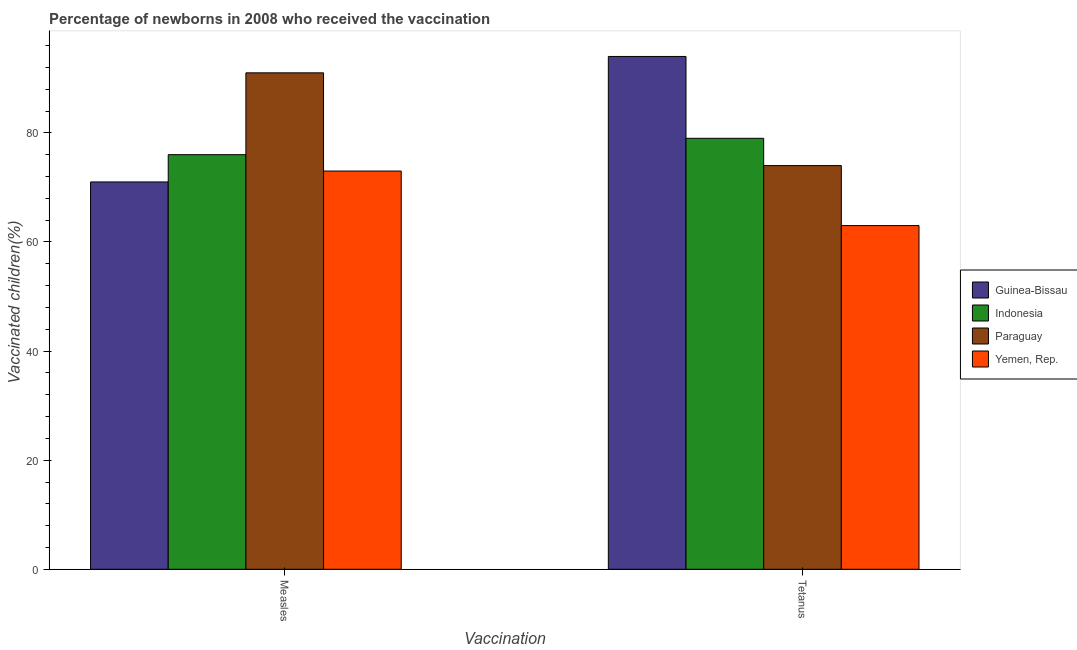Are the number of bars per tick equal to the number of legend labels?
Your answer should be very brief. Yes. Are the number of bars on each tick of the X-axis equal?
Your response must be concise. Yes. How many bars are there on the 1st tick from the left?
Ensure brevity in your answer.  4. How many bars are there on the 2nd tick from the right?
Provide a short and direct response. 4. What is the label of the 2nd group of bars from the left?
Give a very brief answer. Tetanus. What is the percentage of newborns who received vaccination for measles in Guinea-Bissau?
Ensure brevity in your answer.  71. Across all countries, what is the maximum percentage of newborns who received vaccination for measles?
Your response must be concise. 91. Across all countries, what is the minimum percentage of newborns who received vaccination for measles?
Your response must be concise. 71. In which country was the percentage of newborns who received vaccination for measles maximum?
Provide a succinct answer. Paraguay. In which country was the percentage of newborns who received vaccination for tetanus minimum?
Ensure brevity in your answer.  Yemen, Rep. What is the total percentage of newborns who received vaccination for tetanus in the graph?
Your answer should be very brief. 310. What is the difference between the percentage of newborns who received vaccination for tetanus in Guinea-Bissau and that in Paraguay?
Keep it short and to the point. 20. What is the difference between the percentage of newborns who received vaccination for measles in Indonesia and the percentage of newborns who received vaccination for tetanus in Paraguay?
Your response must be concise. 2. What is the average percentage of newborns who received vaccination for tetanus per country?
Your answer should be very brief. 77.5. What is the difference between the percentage of newborns who received vaccination for tetanus and percentage of newborns who received vaccination for measles in Yemen, Rep.?
Offer a very short reply. -10. What is the ratio of the percentage of newborns who received vaccination for measles in Yemen, Rep. to that in Paraguay?
Ensure brevity in your answer.  0.8. Is the percentage of newborns who received vaccination for measles in Paraguay less than that in Indonesia?
Keep it short and to the point. No. In how many countries, is the percentage of newborns who received vaccination for measles greater than the average percentage of newborns who received vaccination for measles taken over all countries?
Provide a succinct answer. 1. What does the 1st bar from the left in Tetanus represents?
Offer a terse response. Guinea-Bissau. What does the 1st bar from the right in Measles represents?
Give a very brief answer. Yemen, Rep. How many bars are there?
Make the answer very short. 8. Are all the bars in the graph horizontal?
Offer a very short reply. No. How many countries are there in the graph?
Keep it short and to the point. 4. Are the values on the major ticks of Y-axis written in scientific E-notation?
Provide a short and direct response. No. Does the graph contain grids?
Ensure brevity in your answer.  No. Where does the legend appear in the graph?
Your answer should be very brief. Center right. How many legend labels are there?
Provide a succinct answer. 4. How are the legend labels stacked?
Provide a short and direct response. Vertical. What is the title of the graph?
Your answer should be compact. Percentage of newborns in 2008 who received the vaccination. Does "French Polynesia" appear as one of the legend labels in the graph?
Make the answer very short. No. What is the label or title of the X-axis?
Give a very brief answer. Vaccination. What is the label or title of the Y-axis?
Your response must be concise. Vaccinated children(%)
. What is the Vaccinated children(%)
 of Guinea-Bissau in Measles?
Provide a short and direct response. 71. What is the Vaccinated children(%)
 of Paraguay in Measles?
Your response must be concise. 91. What is the Vaccinated children(%)
 of Guinea-Bissau in Tetanus?
Your response must be concise. 94. What is the Vaccinated children(%)
 in Indonesia in Tetanus?
Your response must be concise. 79. Across all Vaccination, what is the maximum Vaccinated children(%)
 of Guinea-Bissau?
Your answer should be compact. 94. Across all Vaccination, what is the maximum Vaccinated children(%)
 of Indonesia?
Your answer should be very brief. 79. Across all Vaccination, what is the maximum Vaccinated children(%)
 in Paraguay?
Give a very brief answer. 91. Across all Vaccination, what is the minimum Vaccinated children(%)
 in Indonesia?
Offer a terse response. 76. What is the total Vaccinated children(%)
 in Guinea-Bissau in the graph?
Give a very brief answer. 165. What is the total Vaccinated children(%)
 of Indonesia in the graph?
Your answer should be very brief. 155. What is the total Vaccinated children(%)
 in Paraguay in the graph?
Ensure brevity in your answer.  165. What is the total Vaccinated children(%)
 in Yemen, Rep. in the graph?
Provide a short and direct response. 136. What is the difference between the Vaccinated children(%)
 of Guinea-Bissau in Measles and that in Tetanus?
Give a very brief answer. -23. What is the difference between the Vaccinated children(%)
 in Guinea-Bissau in Measles and the Vaccinated children(%)
 in Paraguay in Tetanus?
Give a very brief answer. -3. What is the difference between the Vaccinated children(%)
 in Guinea-Bissau in Measles and the Vaccinated children(%)
 in Yemen, Rep. in Tetanus?
Provide a short and direct response. 8. What is the difference between the Vaccinated children(%)
 of Indonesia in Measles and the Vaccinated children(%)
 of Paraguay in Tetanus?
Make the answer very short. 2. What is the difference between the Vaccinated children(%)
 in Paraguay in Measles and the Vaccinated children(%)
 in Yemen, Rep. in Tetanus?
Provide a succinct answer. 28. What is the average Vaccinated children(%)
 in Guinea-Bissau per Vaccination?
Offer a very short reply. 82.5. What is the average Vaccinated children(%)
 of Indonesia per Vaccination?
Ensure brevity in your answer.  77.5. What is the average Vaccinated children(%)
 in Paraguay per Vaccination?
Ensure brevity in your answer.  82.5. What is the average Vaccinated children(%)
 of Yemen, Rep. per Vaccination?
Provide a succinct answer. 68. What is the difference between the Vaccinated children(%)
 of Guinea-Bissau and Vaccinated children(%)
 of Indonesia in Measles?
Keep it short and to the point. -5. What is the difference between the Vaccinated children(%)
 of Guinea-Bissau and Vaccinated children(%)
 of Paraguay in Measles?
Make the answer very short. -20. What is the difference between the Vaccinated children(%)
 in Indonesia and Vaccinated children(%)
 in Paraguay in Measles?
Give a very brief answer. -15. What is the difference between the Vaccinated children(%)
 of Indonesia and Vaccinated children(%)
 of Yemen, Rep. in Measles?
Provide a succinct answer. 3. What is the difference between the Vaccinated children(%)
 of Guinea-Bissau and Vaccinated children(%)
 of Indonesia in Tetanus?
Provide a succinct answer. 15. What is the difference between the Vaccinated children(%)
 of Guinea-Bissau and Vaccinated children(%)
 of Paraguay in Tetanus?
Make the answer very short. 20. What is the difference between the Vaccinated children(%)
 in Indonesia and Vaccinated children(%)
 in Paraguay in Tetanus?
Your answer should be very brief. 5. What is the difference between the Vaccinated children(%)
 of Indonesia and Vaccinated children(%)
 of Yemen, Rep. in Tetanus?
Your response must be concise. 16. What is the difference between the Vaccinated children(%)
 in Paraguay and Vaccinated children(%)
 in Yemen, Rep. in Tetanus?
Provide a short and direct response. 11. What is the ratio of the Vaccinated children(%)
 of Guinea-Bissau in Measles to that in Tetanus?
Make the answer very short. 0.76. What is the ratio of the Vaccinated children(%)
 of Indonesia in Measles to that in Tetanus?
Give a very brief answer. 0.96. What is the ratio of the Vaccinated children(%)
 of Paraguay in Measles to that in Tetanus?
Your answer should be compact. 1.23. What is the ratio of the Vaccinated children(%)
 in Yemen, Rep. in Measles to that in Tetanus?
Keep it short and to the point. 1.16. What is the difference between the highest and the second highest Vaccinated children(%)
 in Guinea-Bissau?
Ensure brevity in your answer.  23. What is the difference between the highest and the second highest Vaccinated children(%)
 in Paraguay?
Offer a terse response. 17. What is the difference between the highest and the second highest Vaccinated children(%)
 in Yemen, Rep.?
Make the answer very short. 10. What is the difference between the highest and the lowest Vaccinated children(%)
 of Indonesia?
Make the answer very short. 3. 